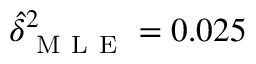<formula> <loc_0><loc_0><loc_500><loc_500>\hat { \delta } _ { M L E } ^ { 2 } = 0 . 0 2 5</formula> 